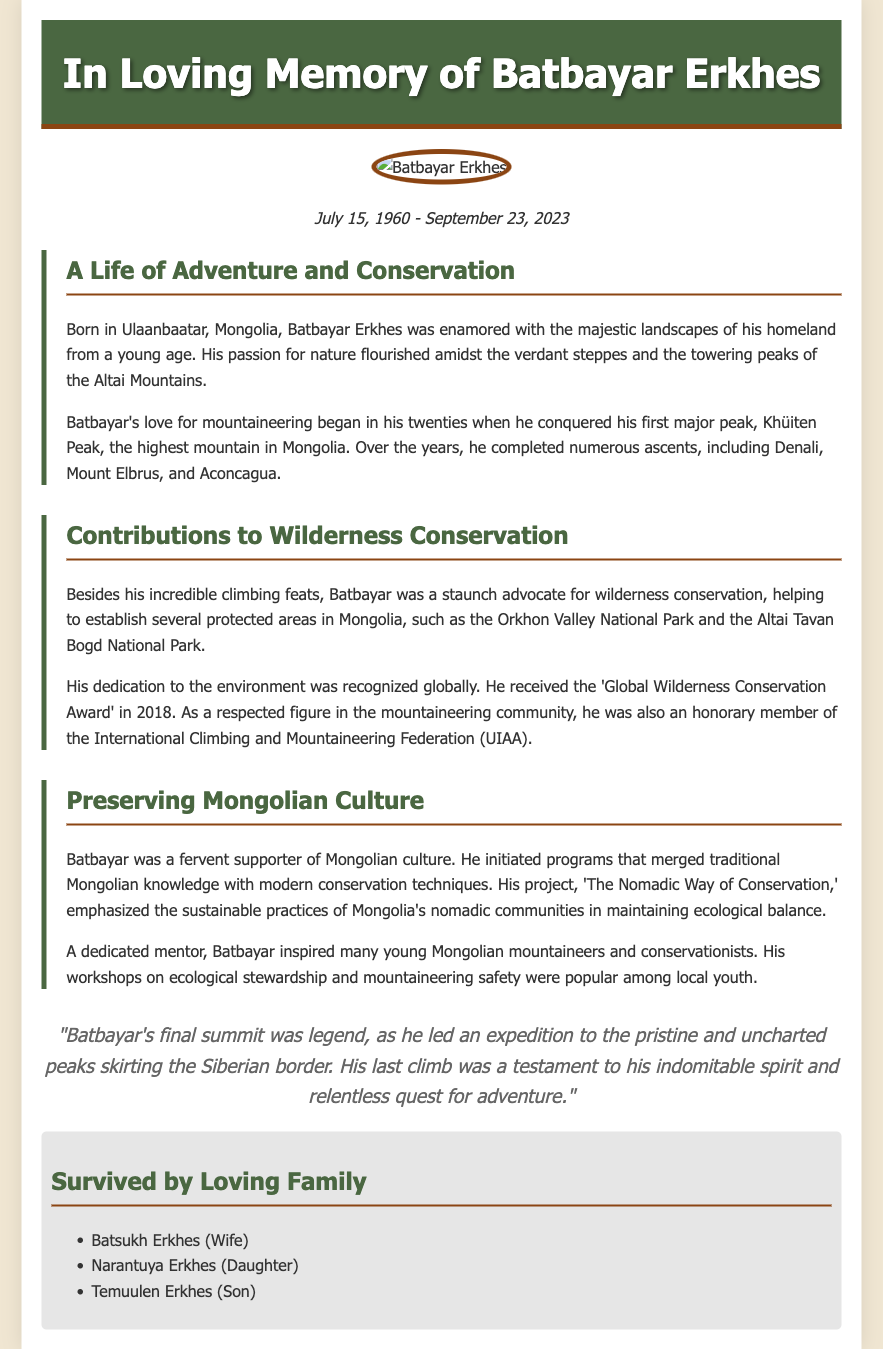What was Batbayar Erkhes's date of birth? Batbayar Erkhes was born on July 15, 1960, as mentioned in the dates section.
Answer: July 15, 1960 When did Batbayar Erkhes pass away? The date of passing is stated as September 23, 2023 in the dates section.
Answer: September 23, 2023 What was the title of Batbayar's project related to conservation? The project is titled 'The Nomadic Way of Conservation,' highlighted in the culture section.
Answer: The Nomadic Way of Conservation Which award did Batbayar receive in 2018? The document mentions that he received the 'Global Wilderness Conservation Award' in 2018.
Answer: Global Wilderness Conservation Award What is Batbayar known for besides mountaineering? He is known for his contributions to wilderness conservation and establishing protected areas in Mongolia.
Answer: Wilderness conservation How many children did Batbayar Erkhes have? The document lists his children as Narantuya and Temuulen, indicating he had two.
Answer: Two What mountain did Batbayar conquer as his first major peak? The first major peak he conquered is mentioned as Khüiten Peak.
Answer: Khüiten Peak What role did Batbayar hold in the International Climbing and Mountaineering Federation? He was an honorary member of the federation, as noted in the document.
Answer: Honorary member 